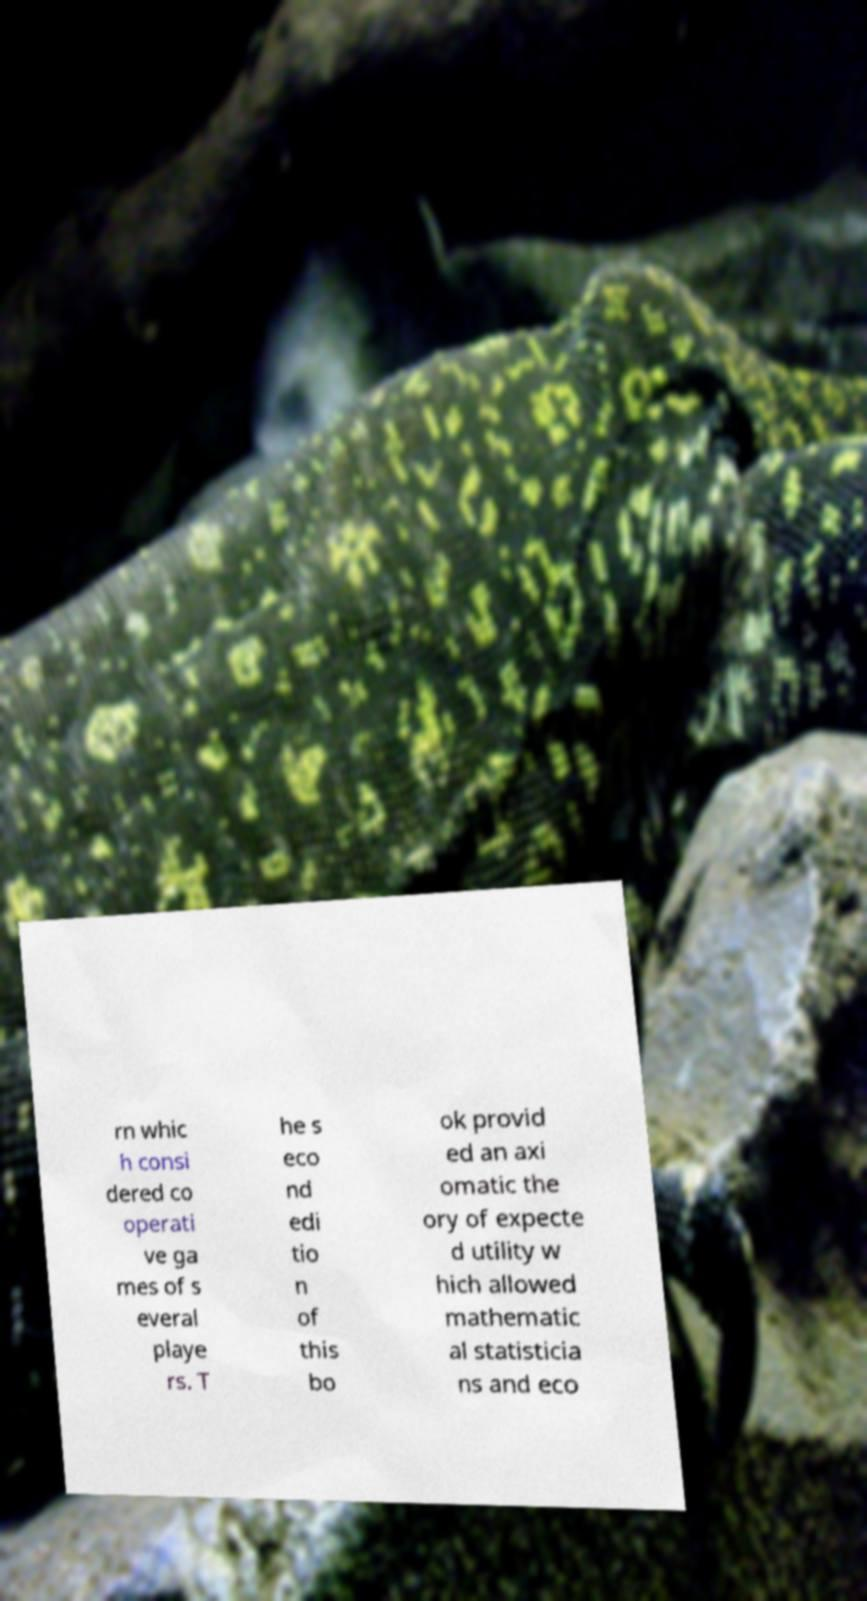Can you read and provide the text displayed in the image?This photo seems to have some interesting text. Can you extract and type it out for me? rn whic h consi dered co operati ve ga mes of s everal playe rs. T he s eco nd edi tio n of this bo ok provid ed an axi omatic the ory of expecte d utility w hich allowed mathematic al statisticia ns and eco 